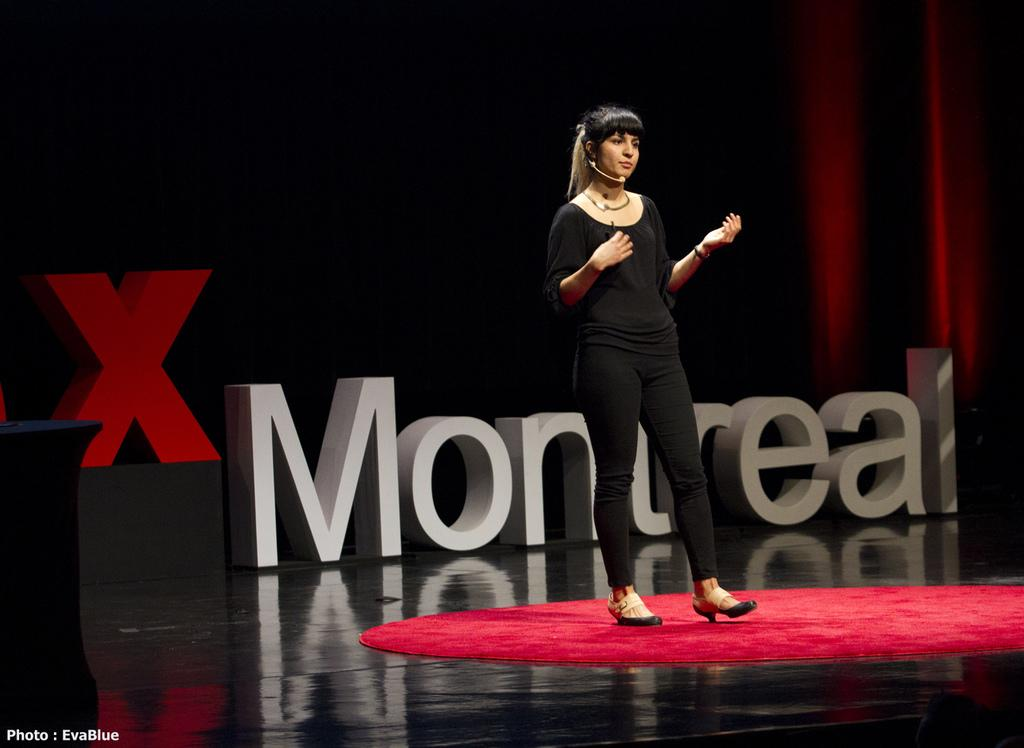What is the lady in the image doing? The lady is standing in the image and holding a microphone. What is on the floor in the image? There is a red carpet on the floor. What can be seen in the background of the image? There is text written in the background. Is there any additional information or branding in the image? Yes, there is a watermark in the left bottom corner of the image. Are there any deer visible on the playground in the image? There is no playground or deer present in the image. 